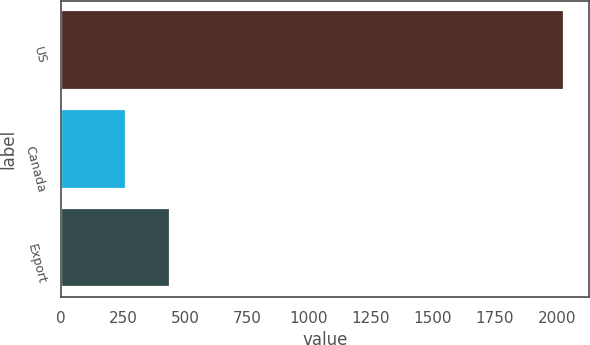<chart> <loc_0><loc_0><loc_500><loc_500><bar_chart><fcel>US<fcel>Canada<fcel>Export<nl><fcel>2029.7<fcel>261.9<fcel>438.68<nl></chart> 